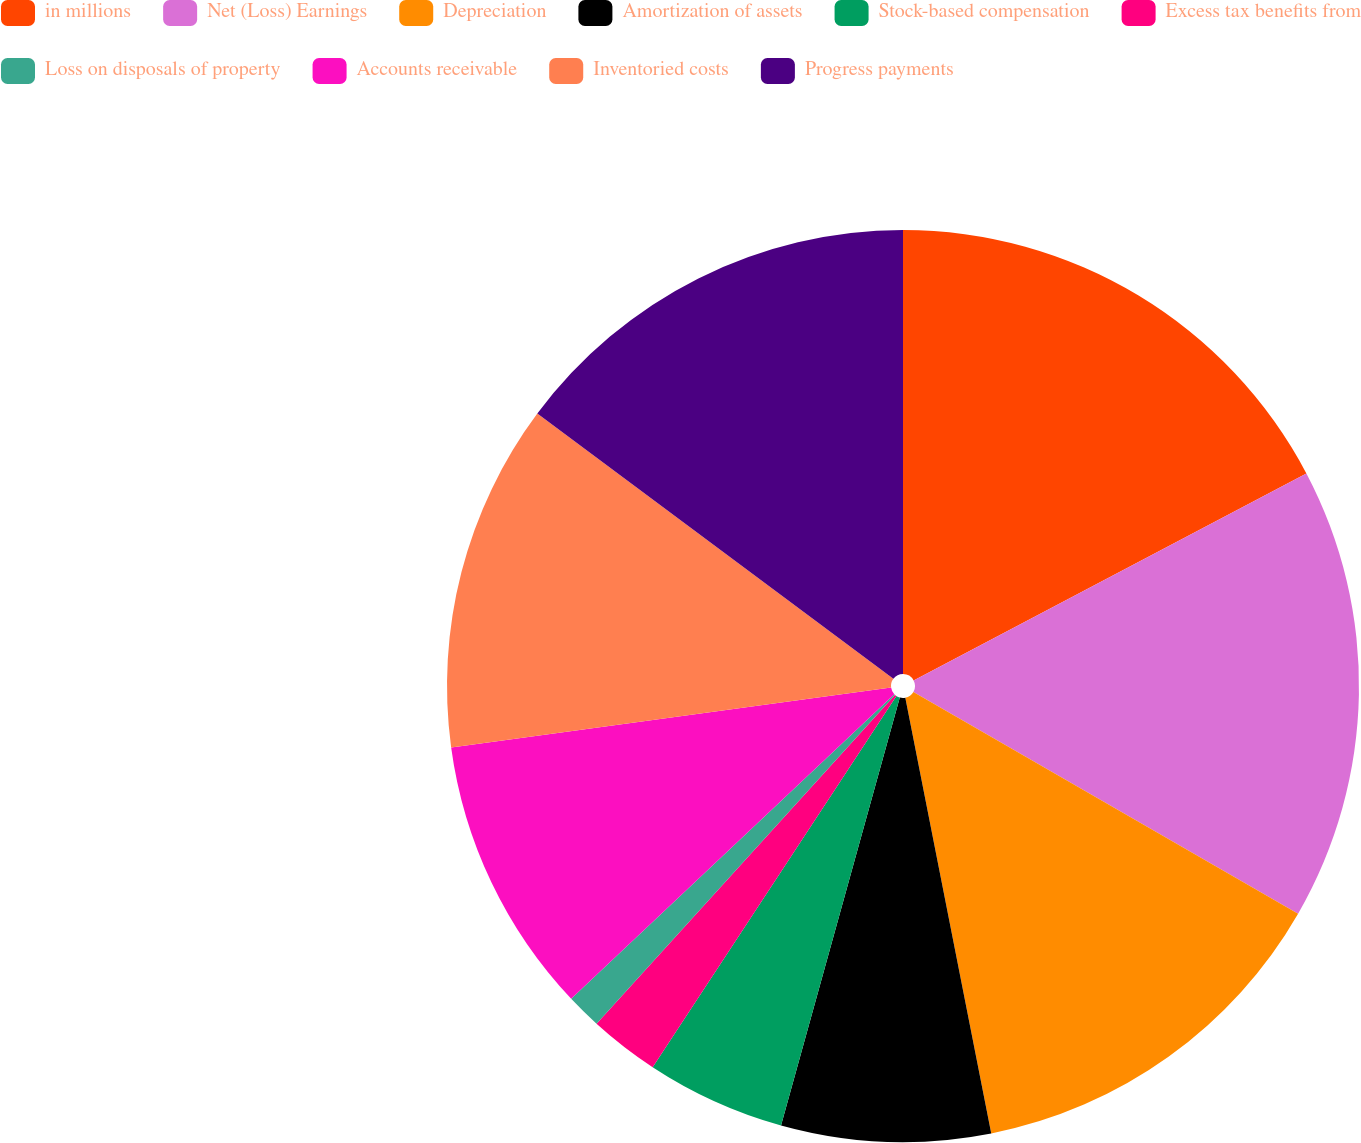Convert chart. <chart><loc_0><loc_0><loc_500><loc_500><pie_chart><fcel>in millions<fcel>Net (Loss) Earnings<fcel>Depreciation<fcel>Amortization of assets<fcel>Stock-based compensation<fcel>Excess tax benefits from<fcel>Loss on disposals of property<fcel>Accounts receivable<fcel>Inventoried costs<fcel>Progress payments<nl><fcel>17.28%<fcel>16.04%<fcel>13.58%<fcel>7.41%<fcel>4.94%<fcel>2.48%<fcel>1.24%<fcel>9.88%<fcel>12.34%<fcel>14.81%<nl></chart> 